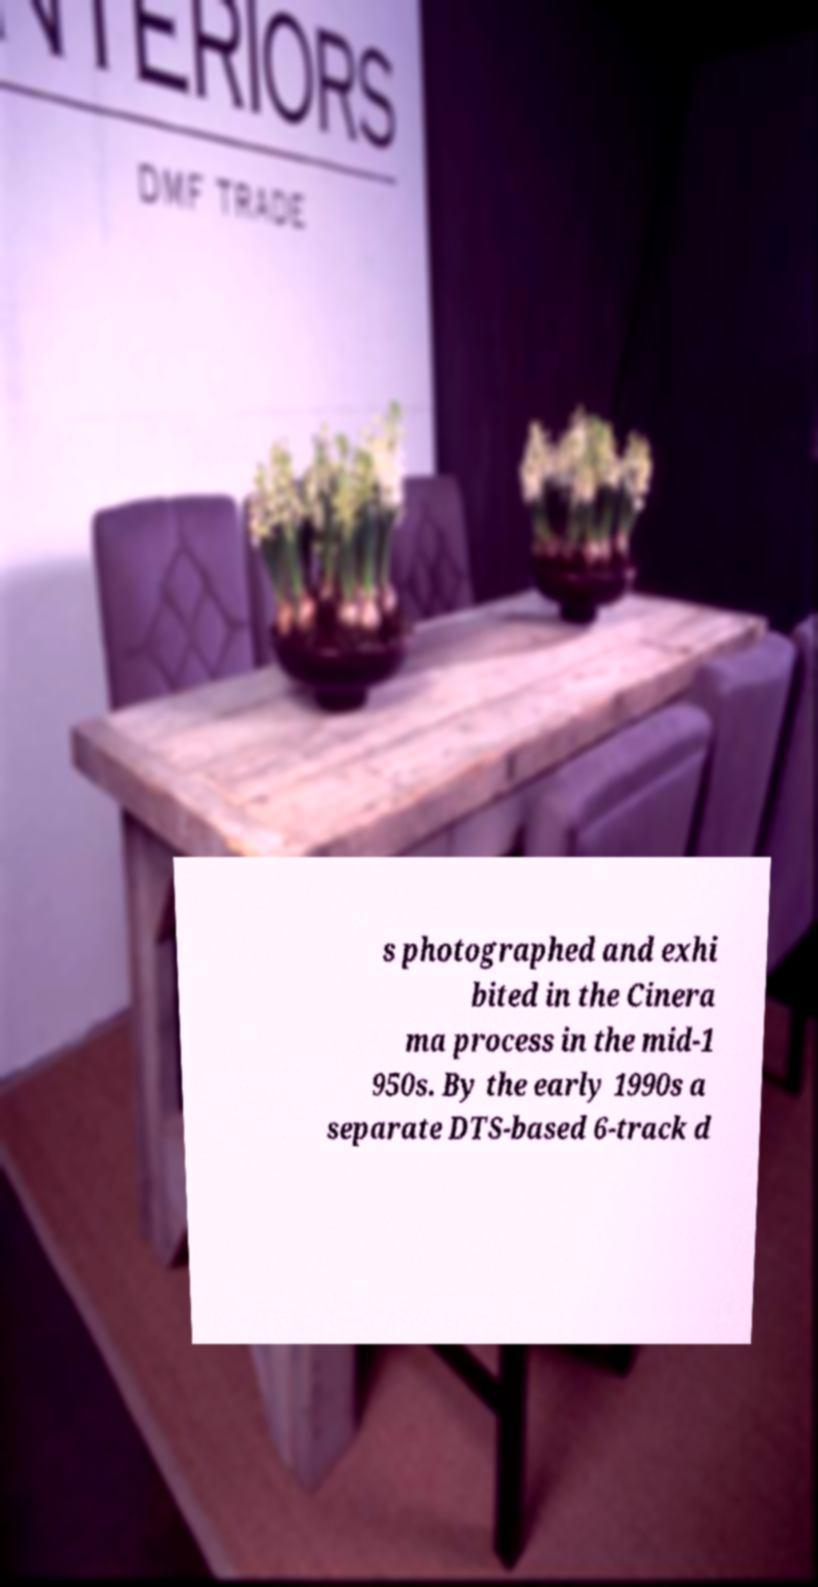Please read and relay the text visible in this image. What does it say? s photographed and exhi bited in the Cinera ma process in the mid-1 950s. By the early 1990s a separate DTS-based 6-track d 